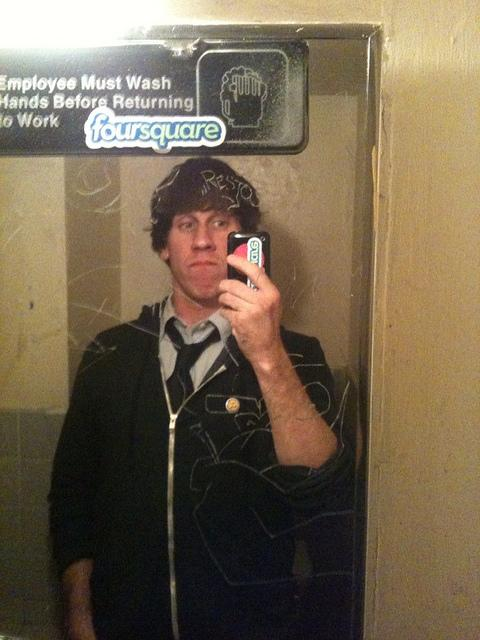Who is taking this man's picture?

Choices:
A) teen friend
B) no one
C) studio photographer
D) he is he is 